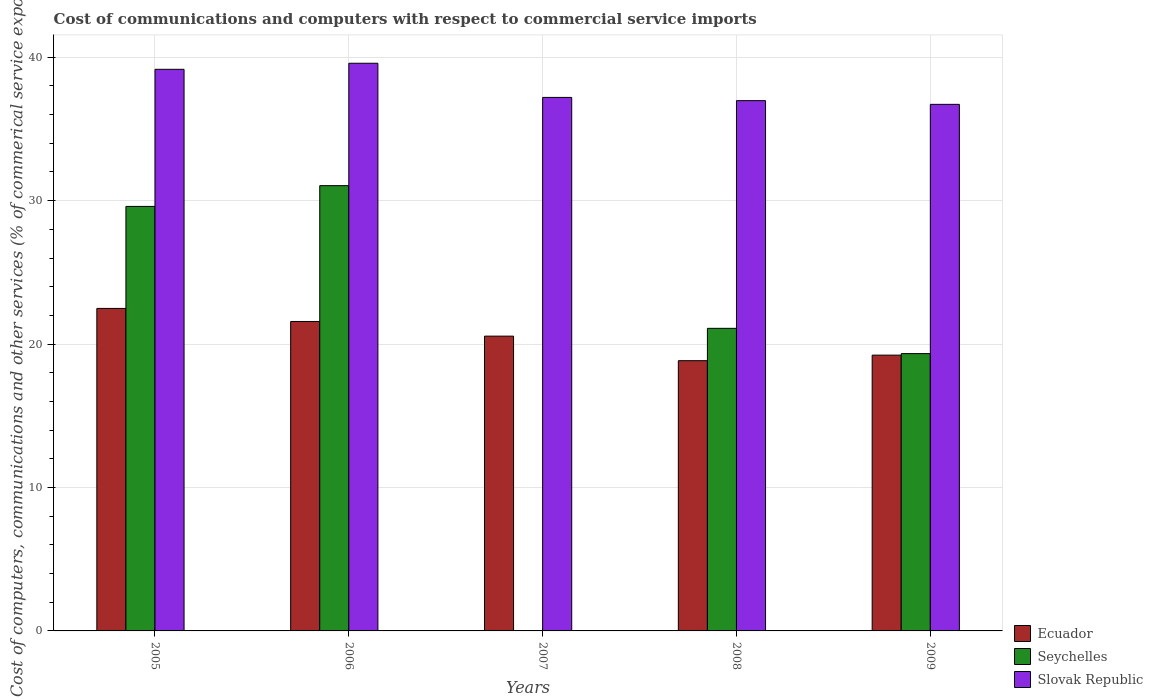How many groups of bars are there?
Provide a succinct answer. 5. How many bars are there on the 5th tick from the left?
Ensure brevity in your answer.  3. In how many cases, is the number of bars for a given year not equal to the number of legend labels?
Your answer should be compact. 1. What is the cost of communications and computers in Slovak Republic in 2009?
Keep it short and to the point. 36.72. Across all years, what is the maximum cost of communications and computers in Ecuador?
Your response must be concise. 22.49. Across all years, what is the minimum cost of communications and computers in Slovak Republic?
Keep it short and to the point. 36.72. In which year was the cost of communications and computers in Seychelles maximum?
Your response must be concise. 2006. What is the total cost of communications and computers in Ecuador in the graph?
Make the answer very short. 102.69. What is the difference between the cost of communications and computers in Seychelles in 2005 and that in 2006?
Ensure brevity in your answer.  -1.45. What is the difference between the cost of communications and computers in Ecuador in 2007 and the cost of communications and computers in Slovak Republic in 2006?
Give a very brief answer. -19.03. What is the average cost of communications and computers in Seychelles per year?
Make the answer very short. 20.22. In the year 2009, what is the difference between the cost of communications and computers in Seychelles and cost of communications and computers in Slovak Republic?
Your answer should be compact. -17.38. In how many years, is the cost of communications and computers in Seychelles greater than 34 %?
Your response must be concise. 0. What is the ratio of the cost of communications and computers in Slovak Republic in 2005 to that in 2009?
Provide a succinct answer. 1.07. Is the difference between the cost of communications and computers in Seychelles in 2005 and 2009 greater than the difference between the cost of communications and computers in Slovak Republic in 2005 and 2009?
Offer a terse response. Yes. What is the difference between the highest and the second highest cost of communications and computers in Seychelles?
Keep it short and to the point. 1.45. What is the difference between the highest and the lowest cost of communications and computers in Ecuador?
Provide a succinct answer. 3.64. Is the sum of the cost of communications and computers in Seychelles in 2005 and 2009 greater than the maximum cost of communications and computers in Slovak Republic across all years?
Your answer should be very brief. Yes. How many bars are there?
Keep it short and to the point. 14. Are all the bars in the graph horizontal?
Ensure brevity in your answer.  No. Does the graph contain grids?
Give a very brief answer. Yes. Where does the legend appear in the graph?
Offer a very short reply. Bottom right. What is the title of the graph?
Keep it short and to the point. Cost of communications and computers with respect to commercial service imports. What is the label or title of the X-axis?
Ensure brevity in your answer.  Years. What is the label or title of the Y-axis?
Offer a terse response. Cost of computers, communications and other services (% of commerical service exports). What is the Cost of computers, communications and other services (% of commerical service exports) of Ecuador in 2005?
Provide a succinct answer. 22.49. What is the Cost of computers, communications and other services (% of commerical service exports) in Seychelles in 2005?
Give a very brief answer. 29.6. What is the Cost of computers, communications and other services (% of commerical service exports) of Slovak Republic in 2005?
Make the answer very short. 39.16. What is the Cost of computers, communications and other services (% of commerical service exports) of Ecuador in 2006?
Your response must be concise. 21.58. What is the Cost of computers, communications and other services (% of commerical service exports) in Seychelles in 2006?
Offer a very short reply. 31.05. What is the Cost of computers, communications and other services (% of commerical service exports) in Slovak Republic in 2006?
Offer a very short reply. 39.58. What is the Cost of computers, communications and other services (% of commerical service exports) in Ecuador in 2007?
Make the answer very short. 20.55. What is the Cost of computers, communications and other services (% of commerical service exports) in Seychelles in 2007?
Your answer should be very brief. 0. What is the Cost of computers, communications and other services (% of commerical service exports) in Slovak Republic in 2007?
Offer a terse response. 37.2. What is the Cost of computers, communications and other services (% of commerical service exports) in Ecuador in 2008?
Keep it short and to the point. 18.84. What is the Cost of computers, communications and other services (% of commerical service exports) in Seychelles in 2008?
Provide a succinct answer. 21.1. What is the Cost of computers, communications and other services (% of commerical service exports) of Slovak Republic in 2008?
Keep it short and to the point. 36.97. What is the Cost of computers, communications and other services (% of commerical service exports) in Ecuador in 2009?
Ensure brevity in your answer.  19.23. What is the Cost of computers, communications and other services (% of commerical service exports) in Seychelles in 2009?
Ensure brevity in your answer.  19.34. What is the Cost of computers, communications and other services (% of commerical service exports) in Slovak Republic in 2009?
Provide a short and direct response. 36.72. Across all years, what is the maximum Cost of computers, communications and other services (% of commerical service exports) of Ecuador?
Provide a succinct answer. 22.49. Across all years, what is the maximum Cost of computers, communications and other services (% of commerical service exports) of Seychelles?
Offer a very short reply. 31.05. Across all years, what is the maximum Cost of computers, communications and other services (% of commerical service exports) of Slovak Republic?
Offer a very short reply. 39.58. Across all years, what is the minimum Cost of computers, communications and other services (% of commerical service exports) of Ecuador?
Provide a succinct answer. 18.84. Across all years, what is the minimum Cost of computers, communications and other services (% of commerical service exports) in Slovak Republic?
Your answer should be compact. 36.72. What is the total Cost of computers, communications and other services (% of commerical service exports) in Ecuador in the graph?
Make the answer very short. 102.69. What is the total Cost of computers, communications and other services (% of commerical service exports) of Seychelles in the graph?
Your response must be concise. 101.08. What is the total Cost of computers, communications and other services (% of commerical service exports) in Slovak Republic in the graph?
Keep it short and to the point. 189.63. What is the difference between the Cost of computers, communications and other services (% of commerical service exports) in Ecuador in 2005 and that in 2006?
Provide a succinct answer. 0.91. What is the difference between the Cost of computers, communications and other services (% of commerical service exports) of Seychelles in 2005 and that in 2006?
Make the answer very short. -1.45. What is the difference between the Cost of computers, communications and other services (% of commerical service exports) of Slovak Republic in 2005 and that in 2006?
Your response must be concise. -0.42. What is the difference between the Cost of computers, communications and other services (% of commerical service exports) in Ecuador in 2005 and that in 2007?
Give a very brief answer. 1.93. What is the difference between the Cost of computers, communications and other services (% of commerical service exports) in Slovak Republic in 2005 and that in 2007?
Your answer should be compact. 1.96. What is the difference between the Cost of computers, communications and other services (% of commerical service exports) of Ecuador in 2005 and that in 2008?
Your response must be concise. 3.64. What is the difference between the Cost of computers, communications and other services (% of commerical service exports) in Seychelles in 2005 and that in 2008?
Make the answer very short. 8.5. What is the difference between the Cost of computers, communications and other services (% of commerical service exports) in Slovak Republic in 2005 and that in 2008?
Offer a very short reply. 2.18. What is the difference between the Cost of computers, communications and other services (% of commerical service exports) in Ecuador in 2005 and that in 2009?
Offer a terse response. 3.26. What is the difference between the Cost of computers, communications and other services (% of commerical service exports) of Seychelles in 2005 and that in 2009?
Give a very brief answer. 10.26. What is the difference between the Cost of computers, communications and other services (% of commerical service exports) of Slovak Republic in 2005 and that in 2009?
Ensure brevity in your answer.  2.44. What is the difference between the Cost of computers, communications and other services (% of commerical service exports) of Ecuador in 2006 and that in 2007?
Keep it short and to the point. 1.02. What is the difference between the Cost of computers, communications and other services (% of commerical service exports) of Slovak Republic in 2006 and that in 2007?
Give a very brief answer. 2.38. What is the difference between the Cost of computers, communications and other services (% of commerical service exports) in Ecuador in 2006 and that in 2008?
Your answer should be very brief. 2.73. What is the difference between the Cost of computers, communications and other services (% of commerical service exports) of Seychelles in 2006 and that in 2008?
Give a very brief answer. 9.95. What is the difference between the Cost of computers, communications and other services (% of commerical service exports) of Slovak Republic in 2006 and that in 2008?
Keep it short and to the point. 2.61. What is the difference between the Cost of computers, communications and other services (% of commerical service exports) in Ecuador in 2006 and that in 2009?
Your response must be concise. 2.35. What is the difference between the Cost of computers, communications and other services (% of commerical service exports) in Seychelles in 2006 and that in 2009?
Give a very brief answer. 11.71. What is the difference between the Cost of computers, communications and other services (% of commerical service exports) in Slovak Republic in 2006 and that in 2009?
Your response must be concise. 2.86. What is the difference between the Cost of computers, communications and other services (% of commerical service exports) in Ecuador in 2007 and that in 2008?
Make the answer very short. 1.71. What is the difference between the Cost of computers, communications and other services (% of commerical service exports) in Slovak Republic in 2007 and that in 2008?
Your answer should be compact. 0.23. What is the difference between the Cost of computers, communications and other services (% of commerical service exports) in Ecuador in 2007 and that in 2009?
Give a very brief answer. 1.33. What is the difference between the Cost of computers, communications and other services (% of commerical service exports) of Slovak Republic in 2007 and that in 2009?
Offer a very short reply. 0.48. What is the difference between the Cost of computers, communications and other services (% of commerical service exports) of Ecuador in 2008 and that in 2009?
Your answer should be compact. -0.39. What is the difference between the Cost of computers, communications and other services (% of commerical service exports) in Seychelles in 2008 and that in 2009?
Ensure brevity in your answer.  1.76. What is the difference between the Cost of computers, communications and other services (% of commerical service exports) in Slovak Republic in 2008 and that in 2009?
Give a very brief answer. 0.26. What is the difference between the Cost of computers, communications and other services (% of commerical service exports) in Ecuador in 2005 and the Cost of computers, communications and other services (% of commerical service exports) in Seychelles in 2006?
Your response must be concise. -8.56. What is the difference between the Cost of computers, communications and other services (% of commerical service exports) in Ecuador in 2005 and the Cost of computers, communications and other services (% of commerical service exports) in Slovak Republic in 2006?
Give a very brief answer. -17.09. What is the difference between the Cost of computers, communications and other services (% of commerical service exports) of Seychelles in 2005 and the Cost of computers, communications and other services (% of commerical service exports) of Slovak Republic in 2006?
Your answer should be very brief. -9.98. What is the difference between the Cost of computers, communications and other services (% of commerical service exports) of Ecuador in 2005 and the Cost of computers, communications and other services (% of commerical service exports) of Slovak Republic in 2007?
Offer a terse response. -14.71. What is the difference between the Cost of computers, communications and other services (% of commerical service exports) of Seychelles in 2005 and the Cost of computers, communications and other services (% of commerical service exports) of Slovak Republic in 2007?
Your response must be concise. -7.6. What is the difference between the Cost of computers, communications and other services (% of commerical service exports) in Ecuador in 2005 and the Cost of computers, communications and other services (% of commerical service exports) in Seychelles in 2008?
Offer a very short reply. 1.39. What is the difference between the Cost of computers, communications and other services (% of commerical service exports) in Ecuador in 2005 and the Cost of computers, communications and other services (% of commerical service exports) in Slovak Republic in 2008?
Offer a very short reply. -14.49. What is the difference between the Cost of computers, communications and other services (% of commerical service exports) of Seychelles in 2005 and the Cost of computers, communications and other services (% of commerical service exports) of Slovak Republic in 2008?
Your response must be concise. -7.37. What is the difference between the Cost of computers, communications and other services (% of commerical service exports) of Ecuador in 2005 and the Cost of computers, communications and other services (% of commerical service exports) of Seychelles in 2009?
Provide a succinct answer. 3.15. What is the difference between the Cost of computers, communications and other services (% of commerical service exports) in Ecuador in 2005 and the Cost of computers, communications and other services (% of commerical service exports) in Slovak Republic in 2009?
Provide a succinct answer. -14.23. What is the difference between the Cost of computers, communications and other services (% of commerical service exports) of Seychelles in 2005 and the Cost of computers, communications and other services (% of commerical service exports) of Slovak Republic in 2009?
Provide a short and direct response. -7.12. What is the difference between the Cost of computers, communications and other services (% of commerical service exports) in Ecuador in 2006 and the Cost of computers, communications and other services (% of commerical service exports) in Slovak Republic in 2007?
Your answer should be compact. -15.62. What is the difference between the Cost of computers, communications and other services (% of commerical service exports) in Seychelles in 2006 and the Cost of computers, communications and other services (% of commerical service exports) in Slovak Republic in 2007?
Provide a short and direct response. -6.15. What is the difference between the Cost of computers, communications and other services (% of commerical service exports) in Ecuador in 2006 and the Cost of computers, communications and other services (% of commerical service exports) in Seychelles in 2008?
Offer a very short reply. 0.48. What is the difference between the Cost of computers, communications and other services (% of commerical service exports) in Ecuador in 2006 and the Cost of computers, communications and other services (% of commerical service exports) in Slovak Republic in 2008?
Your answer should be very brief. -15.4. What is the difference between the Cost of computers, communications and other services (% of commerical service exports) of Seychelles in 2006 and the Cost of computers, communications and other services (% of commerical service exports) of Slovak Republic in 2008?
Provide a succinct answer. -5.93. What is the difference between the Cost of computers, communications and other services (% of commerical service exports) of Ecuador in 2006 and the Cost of computers, communications and other services (% of commerical service exports) of Seychelles in 2009?
Ensure brevity in your answer.  2.24. What is the difference between the Cost of computers, communications and other services (% of commerical service exports) in Ecuador in 2006 and the Cost of computers, communications and other services (% of commerical service exports) in Slovak Republic in 2009?
Ensure brevity in your answer.  -15.14. What is the difference between the Cost of computers, communications and other services (% of commerical service exports) in Seychelles in 2006 and the Cost of computers, communications and other services (% of commerical service exports) in Slovak Republic in 2009?
Your answer should be very brief. -5.67. What is the difference between the Cost of computers, communications and other services (% of commerical service exports) of Ecuador in 2007 and the Cost of computers, communications and other services (% of commerical service exports) of Seychelles in 2008?
Your answer should be compact. -0.54. What is the difference between the Cost of computers, communications and other services (% of commerical service exports) of Ecuador in 2007 and the Cost of computers, communications and other services (% of commerical service exports) of Slovak Republic in 2008?
Offer a terse response. -16.42. What is the difference between the Cost of computers, communications and other services (% of commerical service exports) in Ecuador in 2007 and the Cost of computers, communications and other services (% of commerical service exports) in Seychelles in 2009?
Give a very brief answer. 1.22. What is the difference between the Cost of computers, communications and other services (% of commerical service exports) in Ecuador in 2007 and the Cost of computers, communications and other services (% of commerical service exports) in Slovak Republic in 2009?
Ensure brevity in your answer.  -16.16. What is the difference between the Cost of computers, communications and other services (% of commerical service exports) in Ecuador in 2008 and the Cost of computers, communications and other services (% of commerical service exports) in Seychelles in 2009?
Your answer should be compact. -0.49. What is the difference between the Cost of computers, communications and other services (% of commerical service exports) in Ecuador in 2008 and the Cost of computers, communications and other services (% of commerical service exports) in Slovak Republic in 2009?
Provide a short and direct response. -17.87. What is the difference between the Cost of computers, communications and other services (% of commerical service exports) in Seychelles in 2008 and the Cost of computers, communications and other services (% of commerical service exports) in Slovak Republic in 2009?
Provide a succinct answer. -15.62. What is the average Cost of computers, communications and other services (% of commerical service exports) in Ecuador per year?
Your response must be concise. 20.54. What is the average Cost of computers, communications and other services (% of commerical service exports) in Seychelles per year?
Give a very brief answer. 20.22. What is the average Cost of computers, communications and other services (% of commerical service exports) in Slovak Republic per year?
Keep it short and to the point. 37.93. In the year 2005, what is the difference between the Cost of computers, communications and other services (% of commerical service exports) of Ecuador and Cost of computers, communications and other services (% of commerical service exports) of Seychelles?
Your answer should be compact. -7.11. In the year 2005, what is the difference between the Cost of computers, communications and other services (% of commerical service exports) of Ecuador and Cost of computers, communications and other services (% of commerical service exports) of Slovak Republic?
Keep it short and to the point. -16.67. In the year 2005, what is the difference between the Cost of computers, communications and other services (% of commerical service exports) of Seychelles and Cost of computers, communications and other services (% of commerical service exports) of Slovak Republic?
Your answer should be very brief. -9.56. In the year 2006, what is the difference between the Cost of computers, communications and other services (% of commerical service exports) of Ecuador and Cost of computers, communications and other services (% of commerical service exports) of Seychelles?
Your answer should be very brief. -9.47. In the year 2006, what is the difference between the Cost of computers, communications and other services (% of commerical service exports) of Ecuador and Cost of computers, communications and other services (% of commerical service exports) of Slovak Republic?
Your response must be concise. -18. In the year 2006, what is the difference between the Cost of computers, communications and other services (% of commerical service exports) in Seychelles and Cost of computers, communications and other services (% of commerical service exports) in Slovak Republic?
Offer a very short reply. -8.53. In the year 2007, what is the difference between the Cost of computers, communications and other services (% of commerical service exports) in Ecuador and Cost of computers, communications and other services (% of commerical service exports) in Slovak Republic?
Ensure brevity in your answer.  -16.65. In the year 2008, what is the difference between the Cost of computers, communications and other services (% of commerical service exports) of Ecuador and Cost of computers, communications and other services (% of commerical service exports) of Seychelles?
Your response must be concise. -2.26. In the year 2008, what is the difference between the Cost of computers, communications and other services (% of commerical service exports) of Ecuador and Cost of computers, communications and other services (% of commerical service exports) of Slovak Republic?
Your answer should be very brief. -18.13. In the year 2008, what is the difference between the Cost of computers, communications and other services (% of commerical service exports) of Seychelles and Cost of computers, communications and other services (% of commerical service exports) of Slovak Republic?
Offer a very short reply. -15.88. In the year 2009, what is the difference between the Cost of computers, communications and other services (% of commerical service exports) of Ecuador and Cost of computers, communications and other services (% of commerical service exports) of Seychelles?
Provide a succinct answer. -0.11. In the year 2009, what is the difference between the Cost of computers, communications and other services (% of commerical service exports) in Ecuador and Cost of computers, communications and other services (% of commerical service exports) in Slovak Republic?
Give a very brief answer. -17.49. In the year 2009, what is the difference between the Cost of computers, communications and other services (% of commerical service exports) in Seychelles and Cost of computers, communications and other services (% of commerical service exports) in Slovak Republic?
Offer a very short reply. -17.38. What is the ratio of the Cost of computers, communications and other services (% of commerical service exports) in Ecuador in 2005 to that in 2006?
Your answer should be compact. 1.04. What is the ratio of the Cost of computers, communications and other services (% of commerical service exports) in Seychelles in 2005 to that in 2006?
Keep it short and to the point. 0.95. What is the ratio of the Cost of computers, communications and other services (% of commerical service exports) of Slovak Republic in 2005 to that in 2006?
Provide a short and direct response. 0.99. What is the ratio of the Cost of computers, communications and other services (% of commerical service exports) in Ecuador in 2005 to that in 2007?
Your answer should be compact. 1.09. What is the ratio of the Cost of computers, communications and other services (% of commerical service exports) of Slovak Republic in 2005 to that in 2007?
Offer a very short reply. 1.05. What is the ratio of the Cost of computers, communications and other services (% of commerical service exports) of Ecuador in 2005 to that in 2008?
Your answer should be compact. 1.19. What is the ratio of the Cost of computers, communications and other services (% of commerical service exports) of Seychelles in 2005 to that in 2008?
Offer a terse response. 1.4. What is the ratio of the Cost of computers, communications and other services (% of commerical service exports) in Slovak Republic in 2005 to that in 2008?
Keep it short and to the point. 1.06. What is the ratio of the Cost of computers, communications and other services (% of commerical service exports) of Ecuador in 2005 to that in 2009?
Ensure brevity in your answer.  1.17. What is the ratio of the Cost of computers, communications and other services (% of commerical service exports) in Seychelles in 2005 to that in 2009?
Provide a short and direct response. 1.53. What is the ratio of the Cost of computers, communications and other services (% of commerical service exports) of Slovak Republic in 2005 to that in 2009?
Your answer should be very brief. 1.07. What is the ratio of the Cost of computers, communications and other services (% of commerical service exports) in Ecuador in 2006 to that in 2007?
Your response must be concise. 1.05. What is the ratio of the Cost of computers, communications and other services (% of commerical service exports) of Slovak Republic in 2006 to that in 2007?
Your response must be concise. 1.06. What is the ratio of the Cost of computers, communications and other services (% of commerical service exports) in Ecuador in 2006 to that in 2008?
Offer a very short reply. 1.15. What is the ratio of the Cost of computers, communications and other services (% of commerical service exports) of Seychelles in 2006 to that in 2008?
Make the answer very short. 1.47. What is the ratio of the Cost of computers, communications and other services (% of commerical service exports) of Slovak Republic in 2006 to that in 2008?
Make the answer very short. 1.07. What is the ratio of the Cost of computers, communications and other services (% of commerical service exports) of Ecuador in 2006 to that in 2009?
Provide a succinct answer. 1.12. What is the ratio of the Cost of computers, communications and other services (% of commerical service exports) of Seychelles in 2006 to that in 2009?
Your response must be concise. 1.61. What is the ratio of the Cost of computers, communications and other services (% of commerical service exports) of Slovak Republic in 2006 to that in 2009?
Offer a very short reply. 1.08. What is the ratio of the Cost of computers, communications and other services (% of commerical service exports) of Ecuador in 2007 to that in 2008?
Your answer should be compact. 1.09. What is the ratio of the Cost of computers, communications and other services (% of commerical service exports) of Slovak Republic in 2007 to that in 2008?
Your response must be concise. 1.01. What is the ratio of the Cost of computers, communications and other services (% of commerical service exports) of Ecuador in 2007 to that in 2009?
Your answer should be compact. 1.07. What is the ratio of the Cost of computers, communications and other services (% of commerical service exports) of Slovak Republic in 2007 to that in 2009?
Make the answer very short. 1.01. What is the ratio of the Cost of computers, communications and other services (% of commerical service exports) in Ecuador in 2008 to that in 2009?
Keep it short and to the point. 0.98. What is the ratio of the Cost of computers, communications and other services (% of commerical service exports) of Seychelles in 2008 to that in 2009?
Your response must be concise. 1.09. What is the ratio of the Cost of computers, communications and other services (% of commerical service exports) of Slovak Republic in 2008 to that in 2009?
Give a very brief answer. 1.01. What is the difference between the highest and the second highest Cost of computers, communications and other services (% of commerical service exports) of Ecuador?
Your response must be concise. 0.91. What is the difference between the highest and the second highest Cost of computers, communications and other services (% of commerical service exports) of Seychelles?
Your answer should be very brief. 1.45. What is the difference between the highest and the second highest Cost of computers, communications and other services (% of commerical service exports) of Slovak Republic?
Make the answer very short. 0.42. What is the difference between the highest and the lowest Cost of computers, communications and other services (% of commerical service exports) in Ecuador?
Provide a short and direct response. 3.64. What is the difference between the highest and the lowest Cost of computers, communications and other services (% of commerical service exports) in Seychelles?
Your answer should be compact. 31.05. What is the difference between the highest and the lowest Cost of computers, communications and other services (% of commerical service exports) in Slovak Republic?
Your answer should be very brief. 2.86. 